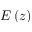<formula> <loc_0><loc_0><loc_500><loc_500>E \left ( z \right )</formula> 